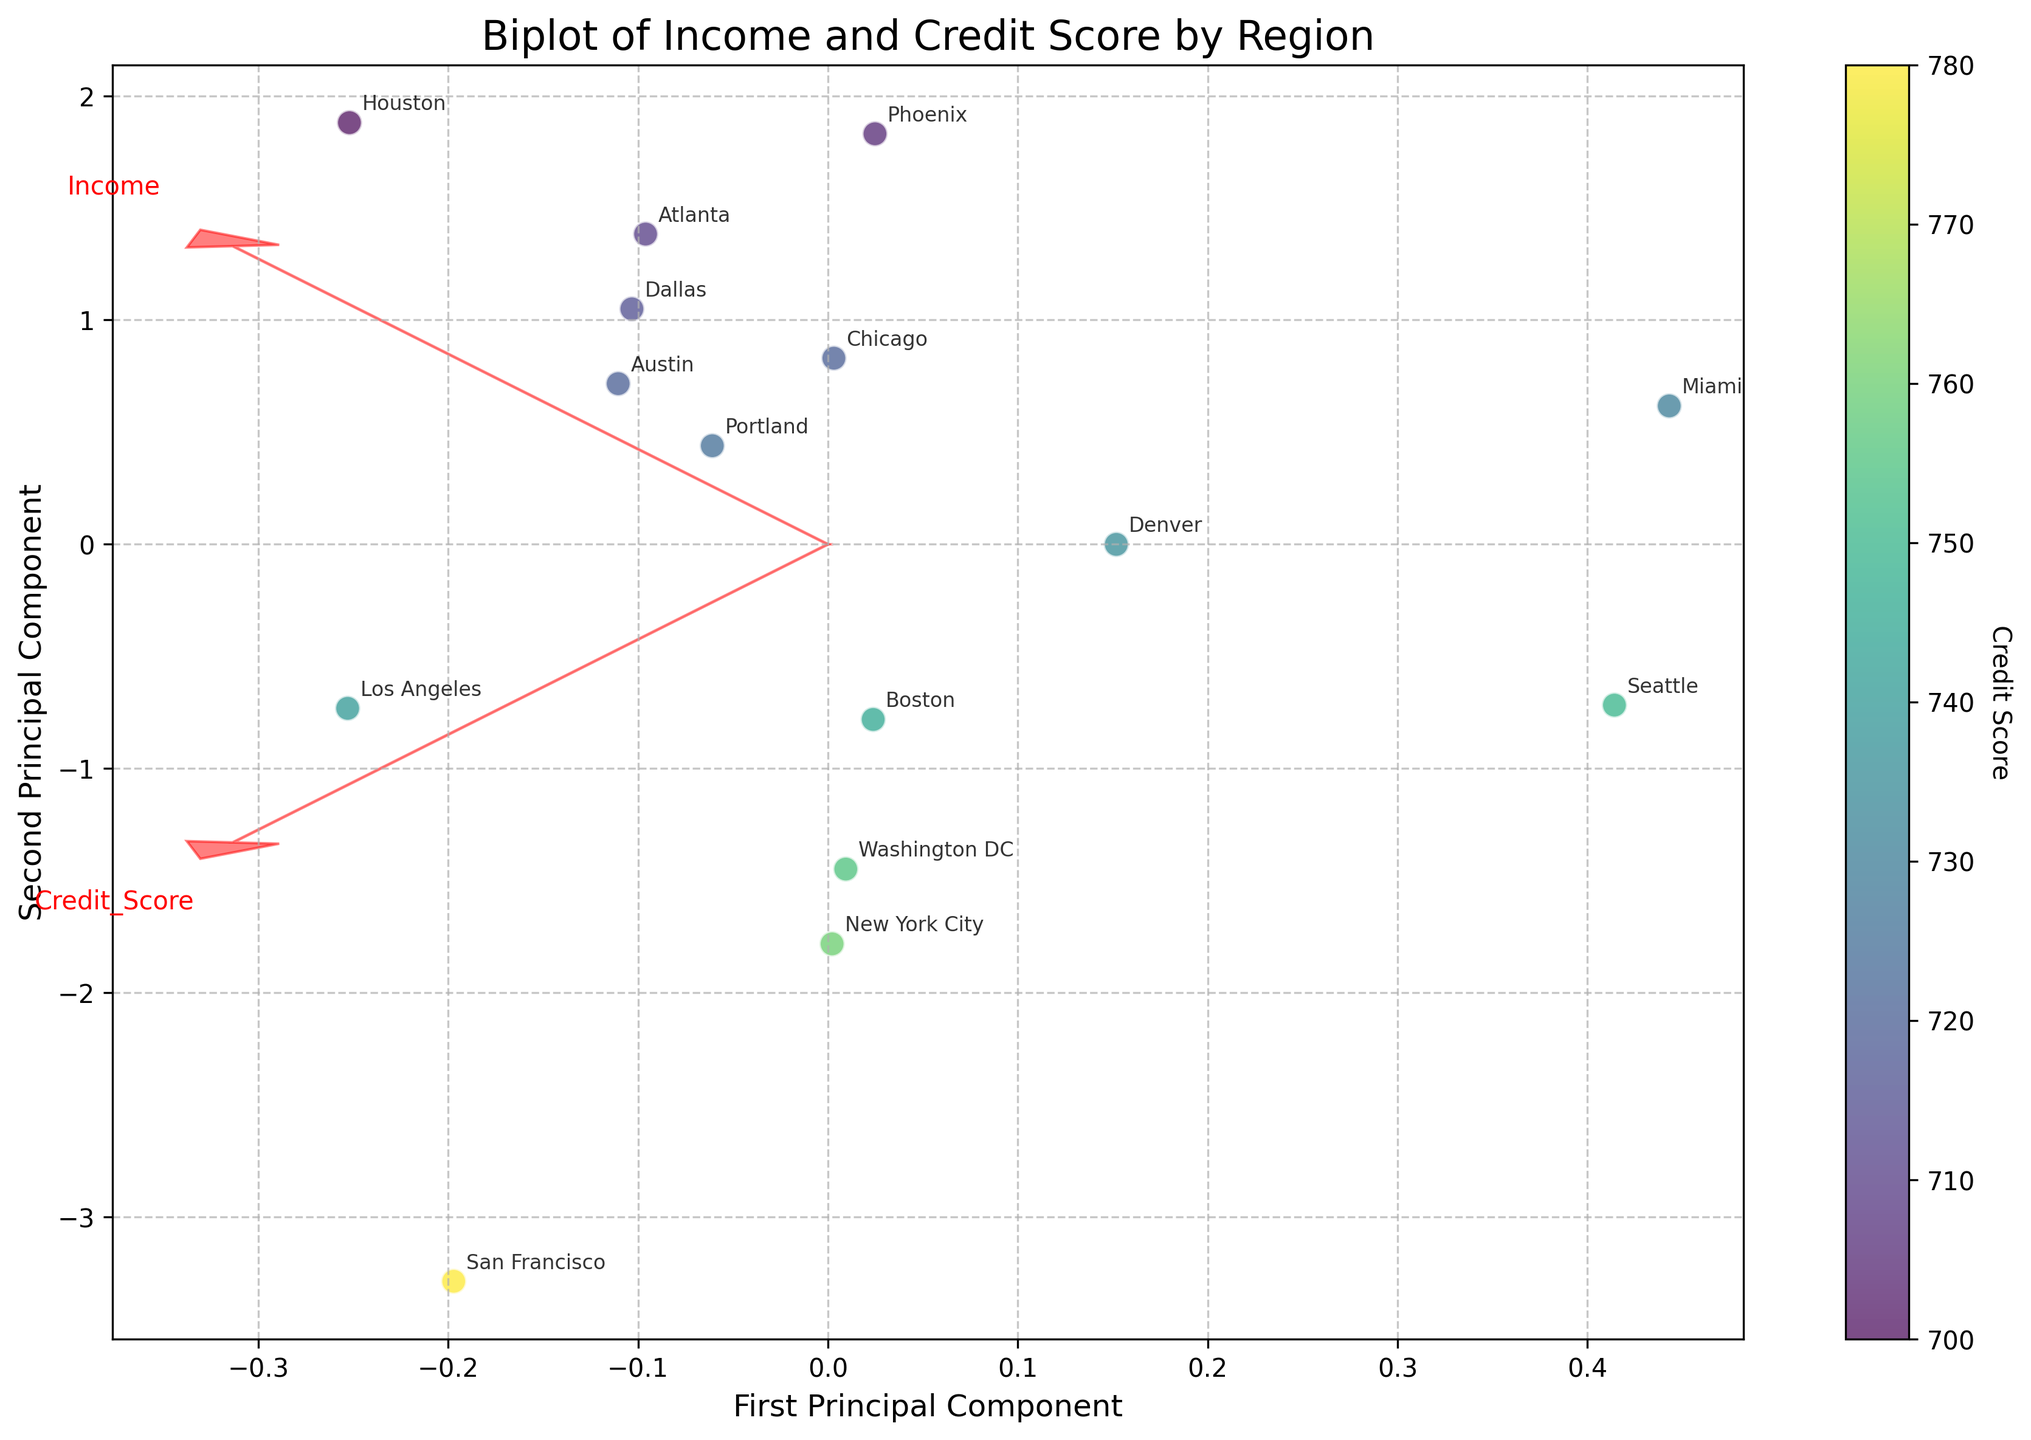How many regions are represented in the biplot? Count the number of different regions annotated in the biplot.
Answer: 15 What is the title of the biplot? Refer to the title text displayed at the top of the biplot.
Answer: Biplot of Income and Credit Score by Region Which region has the highest credit score? Look for the highest value along the color gradient in the plot's colorbar and identify the corresponding annotated region.
Answer: San Francisco Which region has the lowest income level? Find the point closest to the arrow labeled "Income" that is on the negative side of the first principal component axis and identify the corresponding annotated region.
Answer: Phoenix What are the labels on the axes of the biplot? Read the text labels on the horizontal and vertical axes of the biplot.
Answer: First Principal Component, Second Principal Component Which vector indicates the direction of increasing credit score? Identify the arrow labeled "Credit_Score" in the biplot.
Answer: The arrow pointing towards "Credit_Score" Which region is closest to the origin in the biplot? Locate the point closest to (0,0) in the biplot and identify the annotated region.
Answer: Denver How does the income level in New York City compare to that in Los Angeles? Compare the positions of New York City and Los Angeles based on the projection along the "Income" arrow.
Answer: Higher in New York City Which region shows both high income and high credit score? Look for a point positioned in the positive direction of both arrows labeled "Income" and "Credit_Score."
Answer: San Francisco What is indicated by the color of the data points in the biplot? Refer to the color gradient in the colorbar and its label.
Answer: Credit Score 